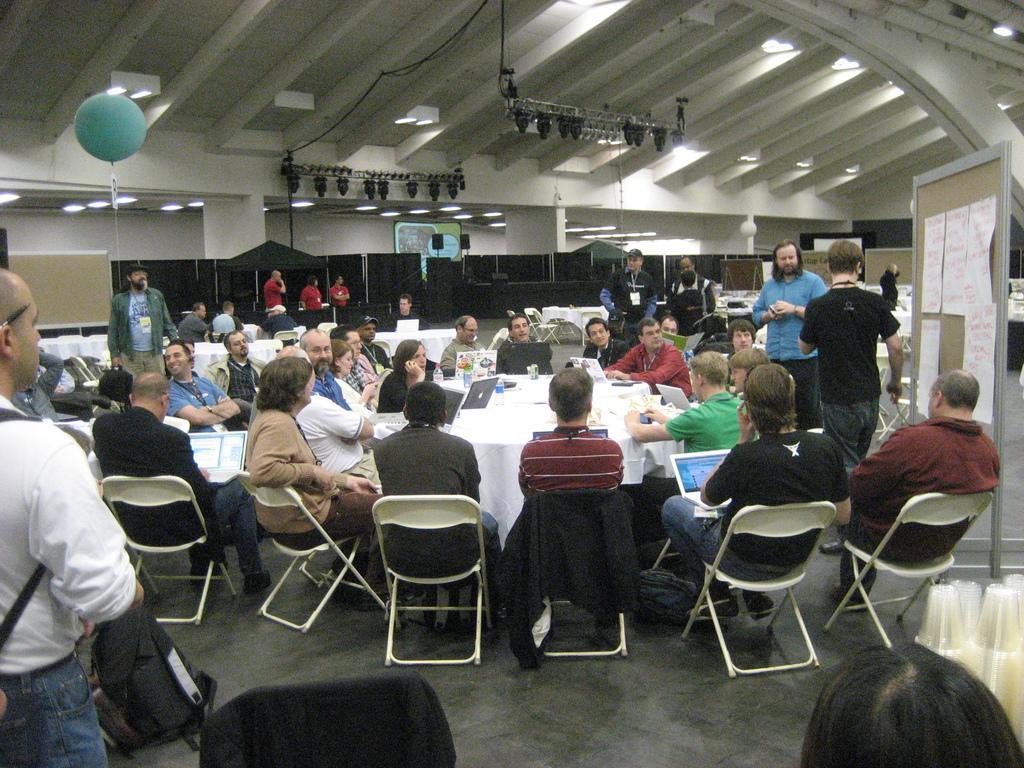In one or two sentences, can you explain what this image depicts? A group of people are sitting around a table and listening to a man. There are few other people standing around. 